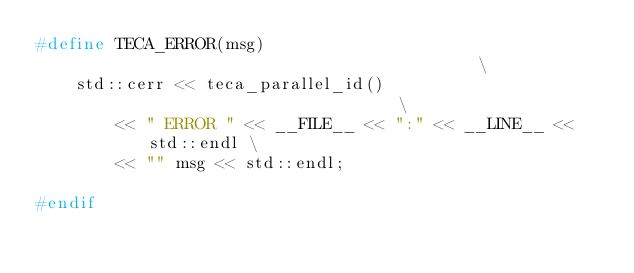<code> <loc_0><loc_0><loc_500><loc_500><_C_>#define TECA_ERROR(msg)                                          \
    std::cerr << teca_parallel_id()                              \
        << " ERROR " << __FILE__ << ":" << __LINE__ << std::endl \
        << "" msg << std::endl;

#endif
</code> 